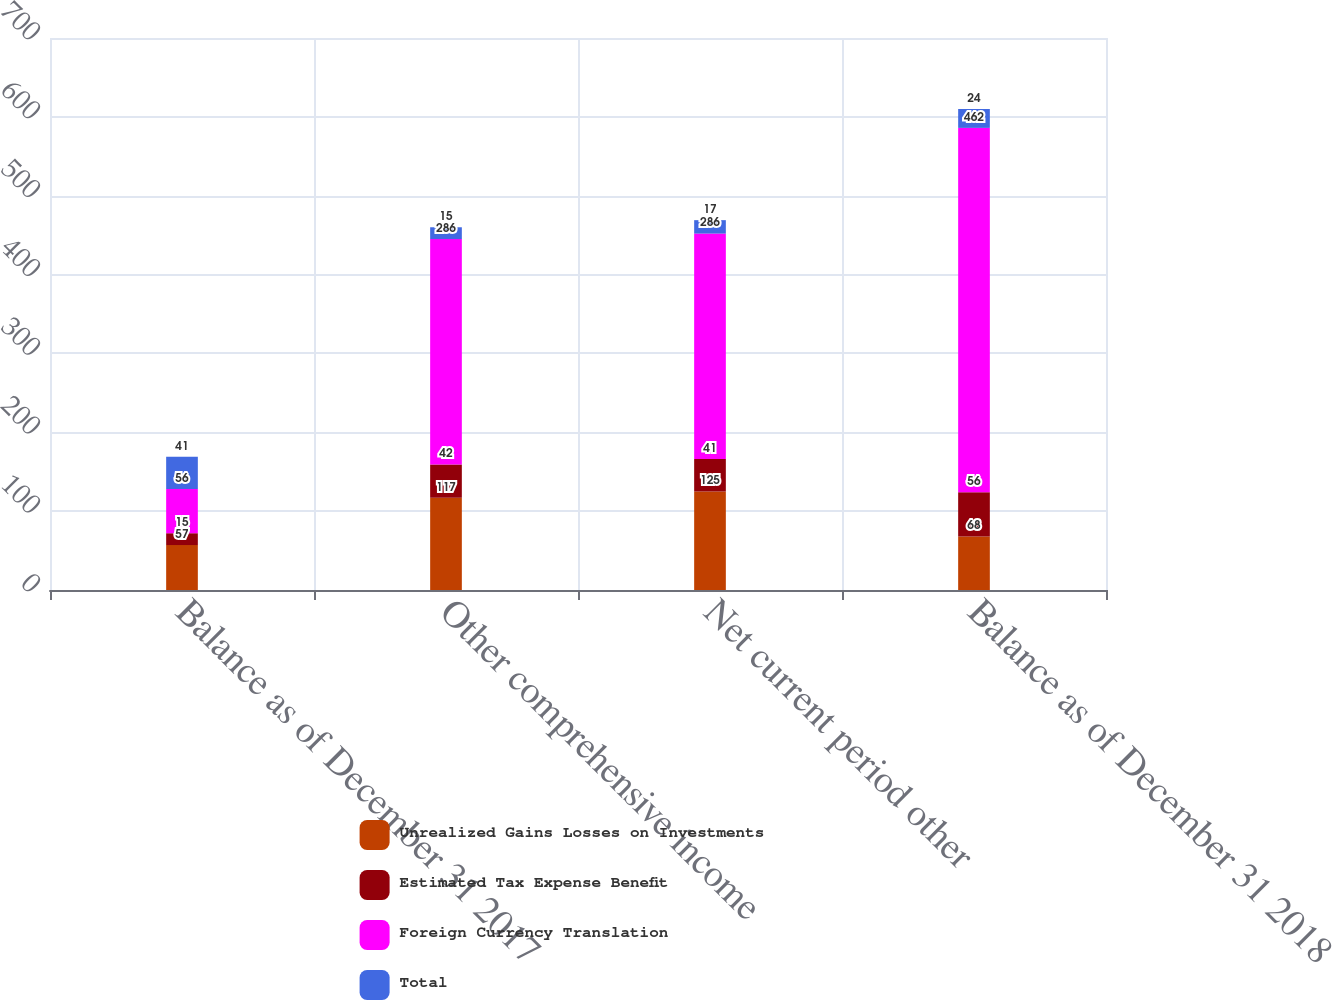Convert chart to OTSL. <chart><loc_0><loc_0><loc_500><loc_500><stacked_bar_chart><ecel><fcel>Balance as of December 31 2017<fcel>Other comprehensive income<fcel>Net current period other<fcel>Balance as of December 31 2018<nl><fcel>Unrealized Gains Losses on Investments<fcel>57<fcel>117<fcel>125<fcel>68<nl><fcel>Estimated Tax Expense Benefit<fcel>15<fcel>42<fcel>41<fcel>56<nl><fcel>Foreign Currency Translation<fcel>56<fcel>286<fcel>286<fcel>462<nl><fcel>Total<fcel>41<fcel>15<fcel>17<fcel>24<nl></chart> 